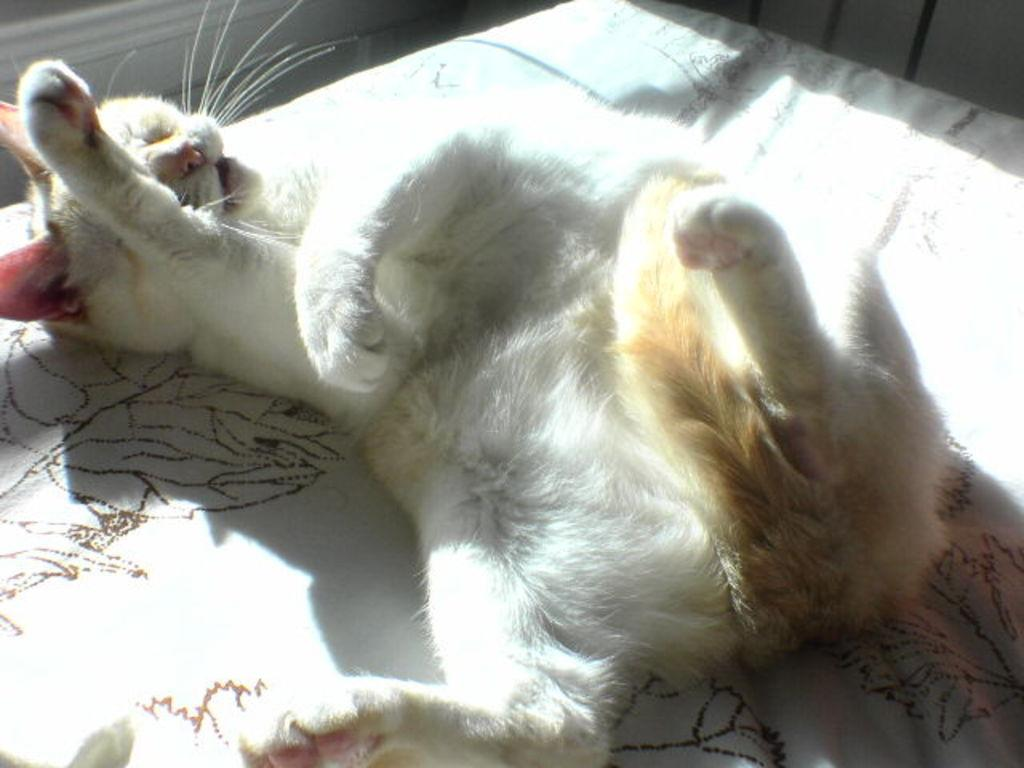What type of animal is in the image? There is a white cat in the image. What is the cat doing in the image? The cat is sleeping. What is the color of the surface the cat is on? The cat is on a white surface. What type of book is the cat holding in the image? There is no book present in the image; the cat is sleeping on a white surface. 